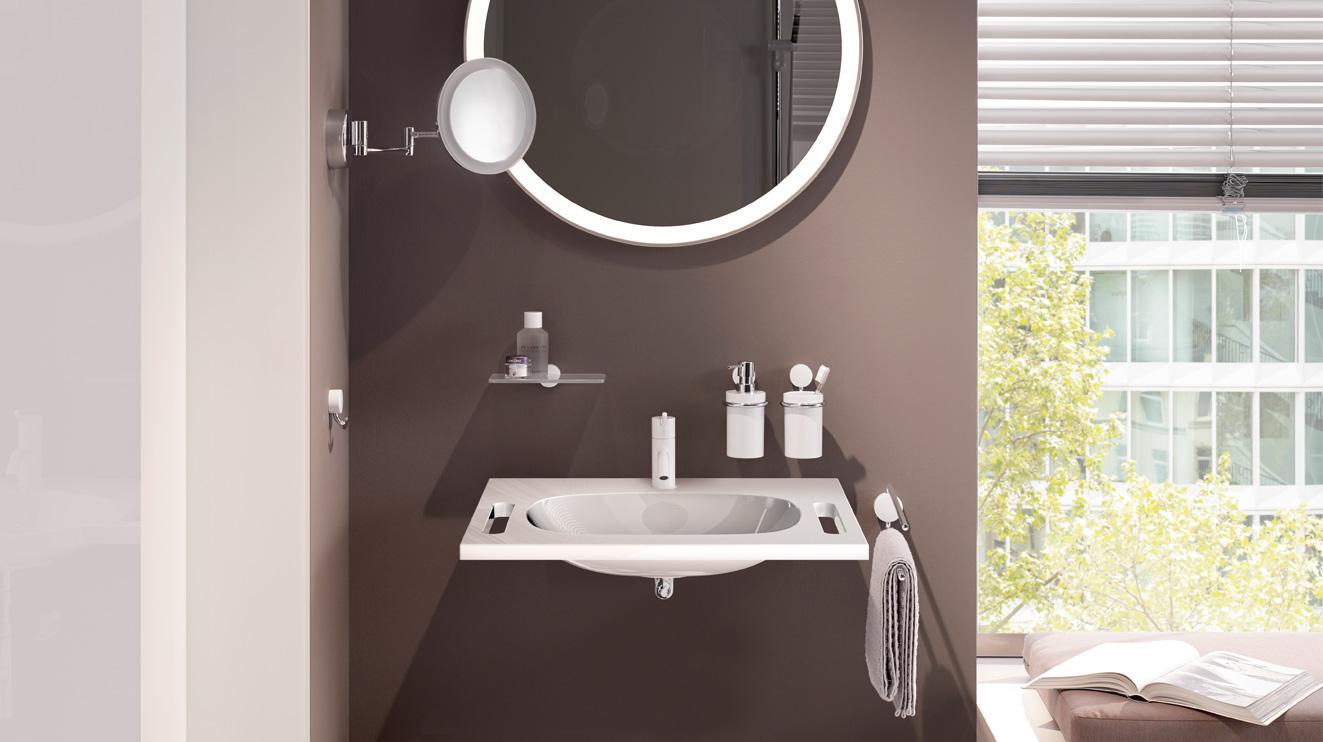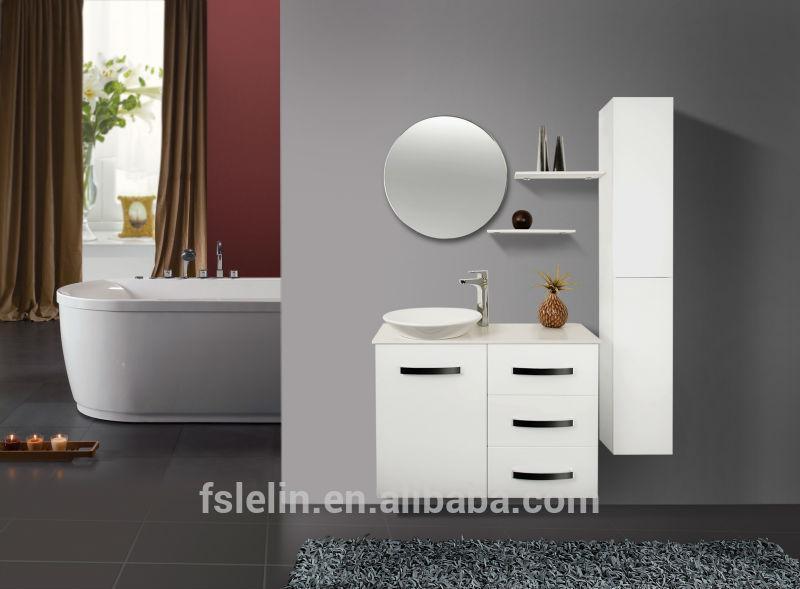The first image is the image on the left, the second image is the image on the right. For the images shown, is this caption "In one image, a wall-mounted bathroom sink with underside visible is shown with a wall mounted mirror, shaving mirror, and two toothbrush holders." true? Answer yes or no. Yes. 